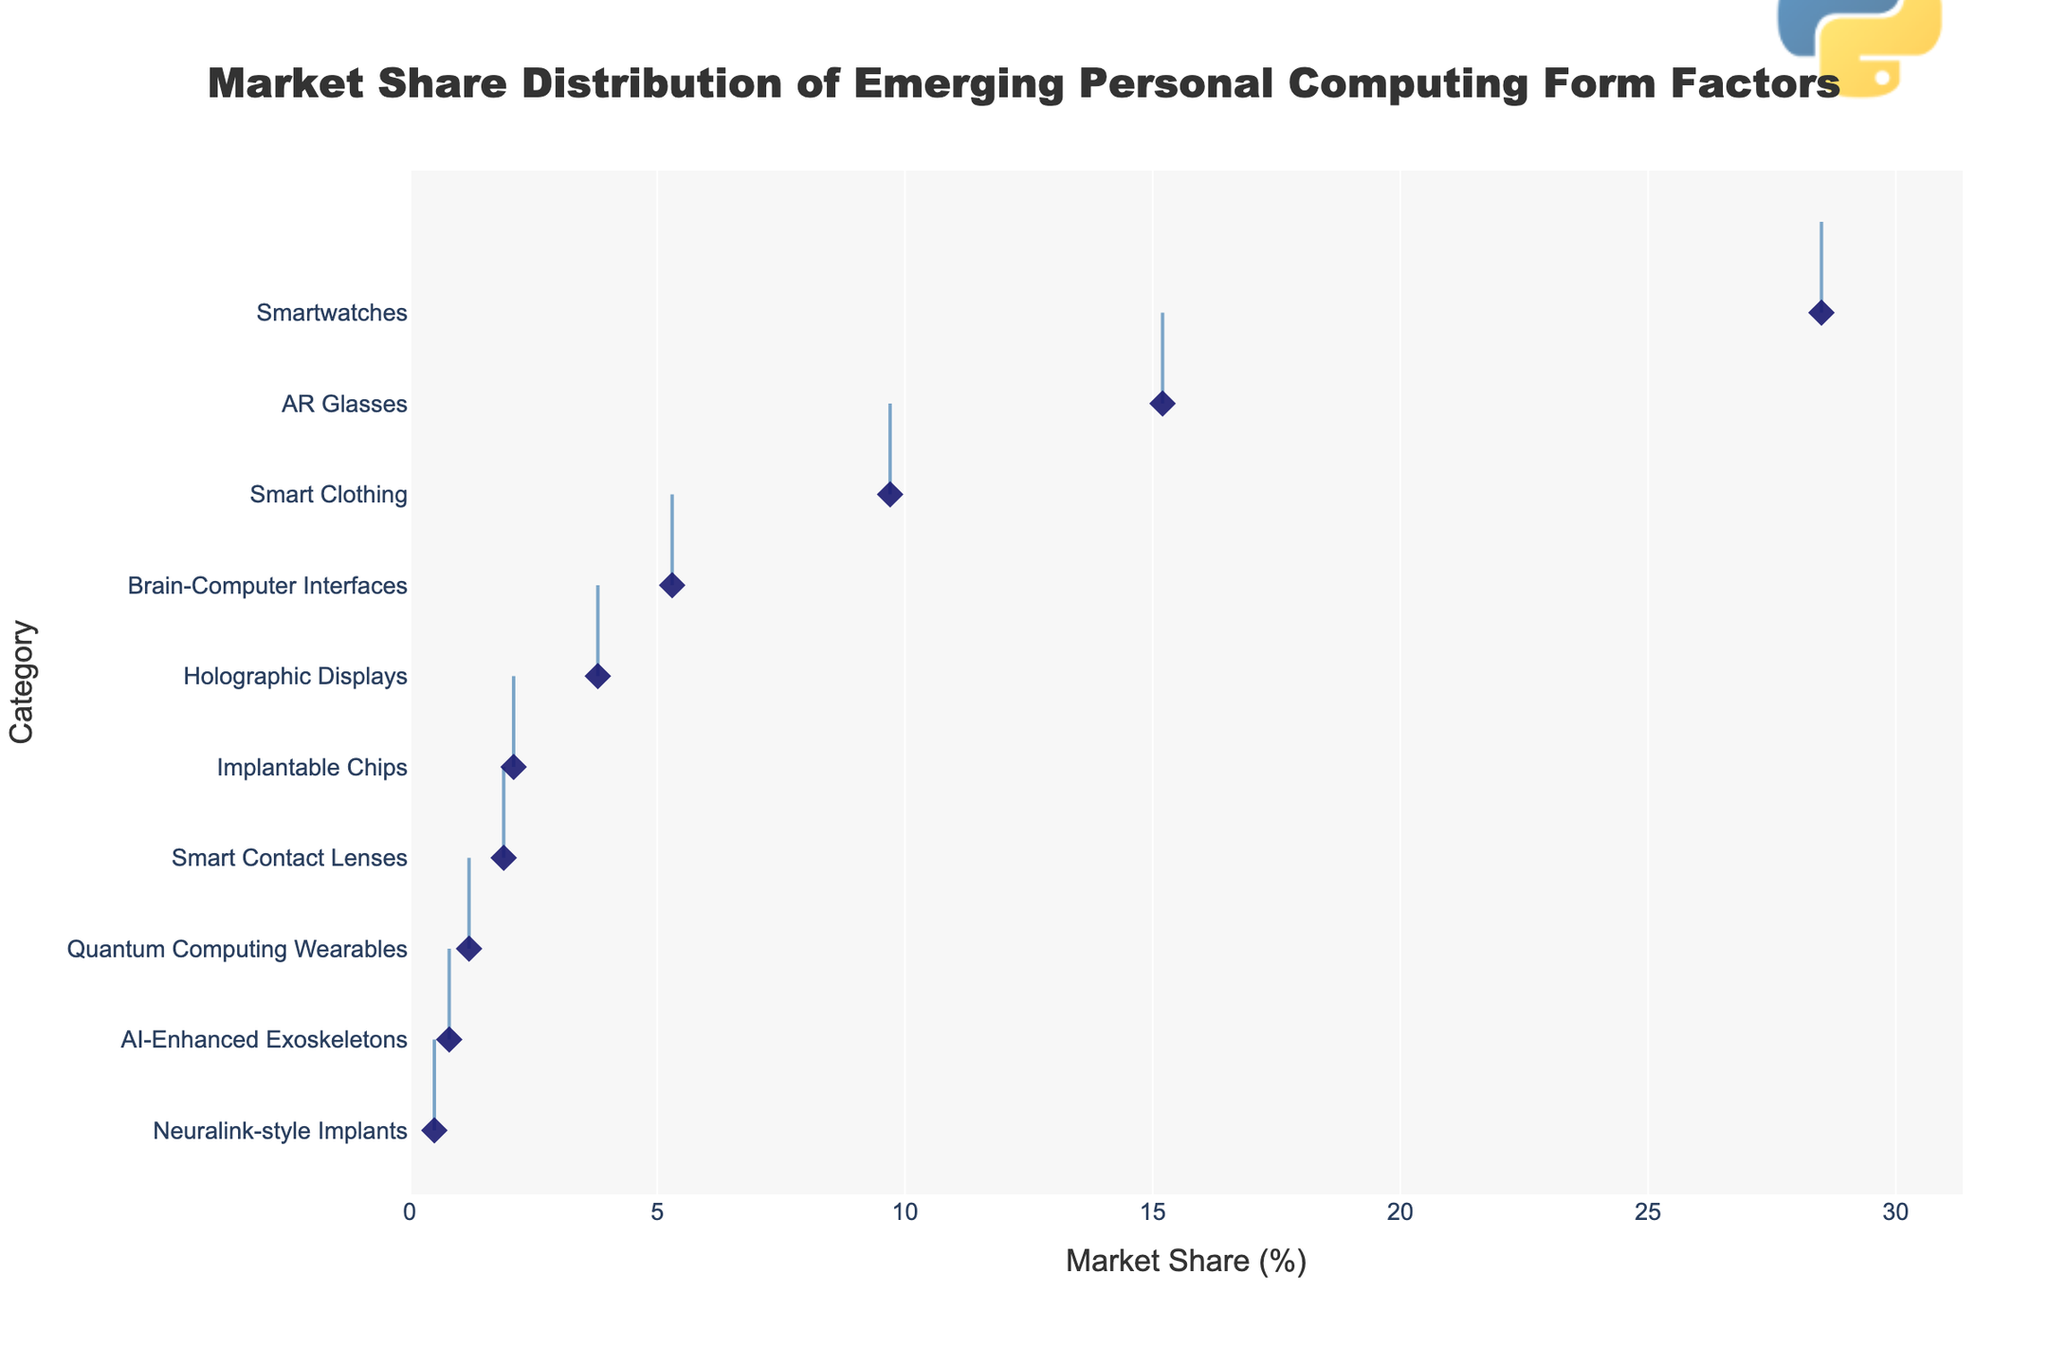What is the highest market share category? The figure reveals that the highest market share percentage is associated with Smartwatches. This observation is based on the fact that the extreme right of the density plot, where the highest x-values are located, corresponds to the 'Smartwatches' category.
Answer: Smartwatches How many categories have a market share above 10%? Looking at the horizontal density plot, we identify categories with their values extending beyond the 10% mark on the x-axis. These categories are 'Smartwatches' and 'AR Glasses'.
Answer: 2 Which category has the smallest market share? The lowest point on the x-axis of the density plot is associated with the 'Neuralink-style Implants' category, which is positioned farthest left.
Answer: Neuralink-style Implants What is the combined market share of the categories ranked second and third? The second and third largest market shares are AR Glasses (15.2%) and Smart Clothing (9.7%), respectively. Summing these yields 15.2 + 9.7.
Answer: 24.9% Is the market share of Holographic Displays greater than that of Brain-Computer Interfaces? By comparing their positions on the x-axis, Brain-Computer Interfaces (5.3%) have a higher market share than Holographic Displays (3.8%).
Answer: No What is the median market share value across all categories? Listing the values in ascending order: 0.5, 0.8, 1.2, 1.9, 2.1, 3.8, 5.3, 9.7, 15.2, 28.5, the median is the average of two middle values: (2.1 + 3.8)/2 = 2.95.
Answer: 2.95% Which category has roughly half the market share of AR Glasses? Identifying the categories by their values, approximately half of AR Glasses' market share (15.2/2 = 7.6) closely matches Smart Clothing's 9.7%.
Answer: Smart Clothing Are there more categories with market share under 5% or above 5%? Counting the categories, market shares under 5% include Neuralink-style Implants, AI-Enhanced Exoskeletons, Quantum Computing Wearables, Smart Contact Lenses, Implantable Chips, and Holographic Displays. While market shares above 5% include Brain-Computer Interfaces, Smart Clothing, AR Glasses, and Smartwatches. The numbers are 6 versus 4.
Answer: Under 5% What is the range of the market shares displayed in the plot? The difference between the maximum and minimum market share values provides the range: 28.5% (Smartwatches) - 0.5% (Neuralink-style Implants).
Answer: 28.0% How does the market share of Brain-Computer Interfaces compare to that of Smart Contact Lenses? Analyzing the x-axis positions reveals that Brain-Computer Interfaces (5.3%) have a higher market share compared to Smart Contact Lenses (1.9%).
Answer: Higher 